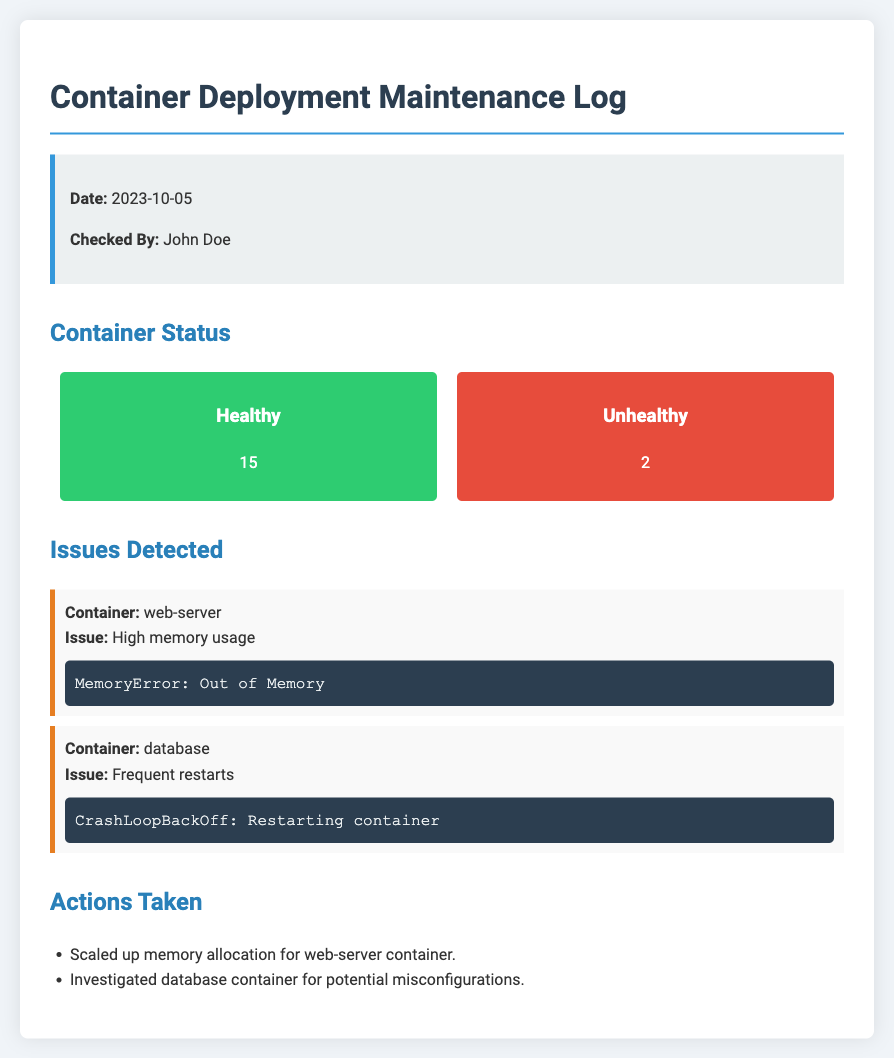What is the date of the log? The date of the log is specified at the beginning of the document under "Date".
Answer: 2023-10-05 Who checked the containers? The person who checked the containers is mentioned under "Checked By".
Answer: John Doe How many containers are unhealthy? The number of unhealthy containers is indicated under "Container Status".
Answer: 2 What issue was detected in the web-server container? The document lists specific issues detected in the respective containers.
Answer: High memory usage What action was taken regarding the web-server container? The actions taken are listed in the "Actions Taken" section.
Answer: Scaled up memory allocation for web-server container What is the total number of healthy containers? The total is found in the "Container Status" section, specifically under healthy containers.
Answer: 15 What was the error log for the database container? The issue related to the database container includes its error log snippet.
Answer: CrashLoopBackOff: Restarting container 